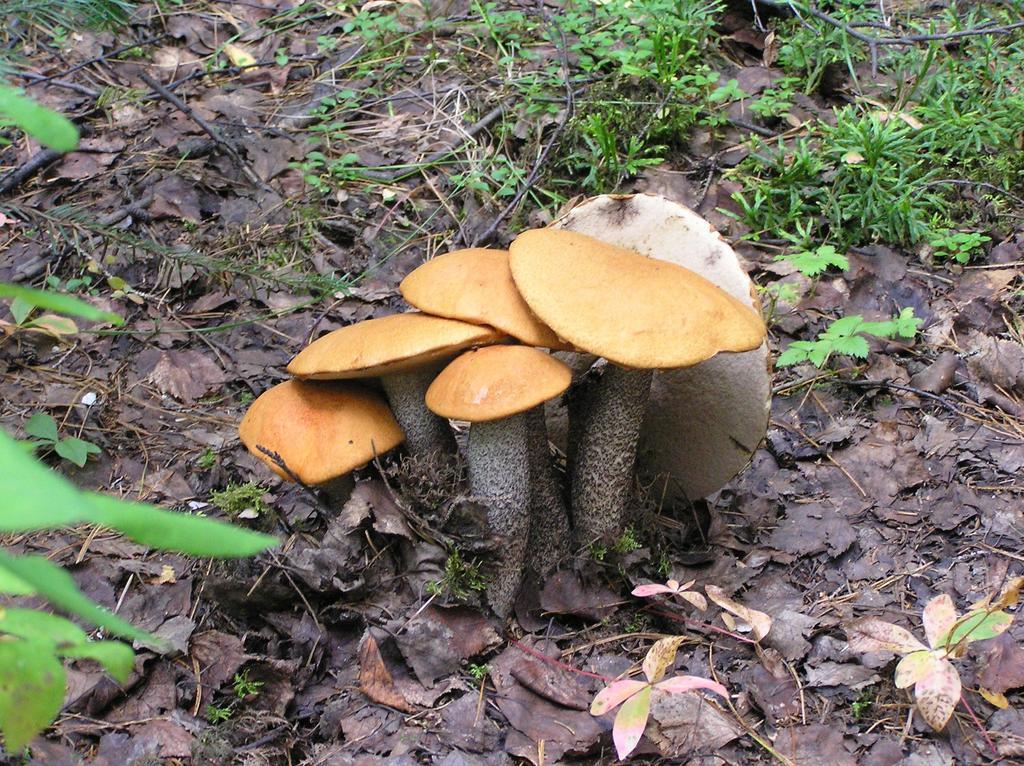Please provide a concise description of this image. In the image there are mushrooms on the land, covered with dry leaves and small plants. 